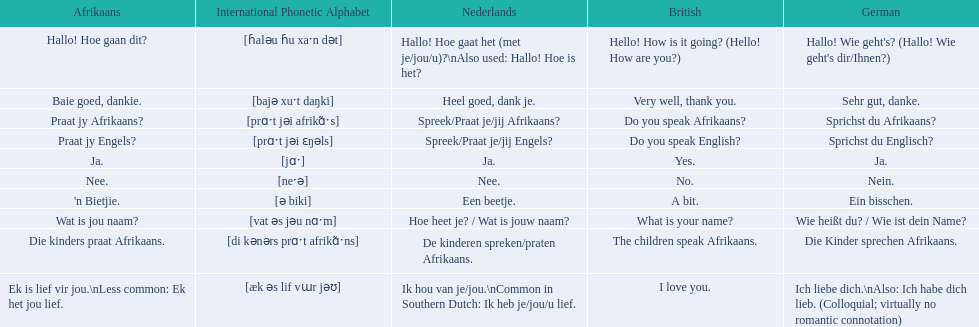In german how do you say do you speak afrikaans? Sprichst du Afrikaans?. Could you parse the entire table? {'header': ['Afrikaans', 'International Phonetic Alphabet', 'Nederlands', 'British', 'German'], 'rows': [['Hallo! Hoe gaan dit?', '[ɦaləu ɦu xaˑn dət]', 'Hallo! Hoe gaat het (met je/jou/u)?\\nAlso used: Hallo! Hoe is het?', 'Hello! How is it going? (Hello! How are you?)', "Hallo! Wie geht's? (Hallo! Wie geht's dir/Ihnen?)"], ['Baie goed, dankie.', '[bajə xuˑt daŋki]', 'Heel goed, dank je.', 'Very well, thank you.', 'Sehr gut, danke.'], ['Praat jy Afrikaans?', '[prɑˑt jəi afrikɑ̃ˑs]', 'Spreek/Praat je/jij Afrikaans?', 'Do you speak Afrikaans?', 'Sprichst du Afrikaans?'], ['Praat jy Engels?', '[prɑˑt jəi ɛŋəls]', 'Spreek/Praat je/jij Engels?', 'Do you speak English?', 'Sprichst du Englisch?'], ['Ja.', '[jɑˑ]', 'Ja.', 'Yes.', 'Ja.'], ['Nee.', '[neˑə]', 'Nee.', 'No.', 'Nein.'], ["'n Bietjie.", '[ə biki]', 'Een beetje.', 'A bit.', 'Ein bisschen.'], ['Wat is jou naam?', '[vat əs jəu nɑˑm]', 'Hoe heet je? / Wat is jouw naam?', 'What is your name?', 'Wie heißt du? / Wie ist dein Name?'], ['Die kinders praat Afrikaans.', '[di kənərs prɑˑt afrikɑ̃ˑns]', 'De kinderen spreken/praten Afrikaans.', 'The children speak Afrikaans.', 'Die Kinder sprechen Afrikaans.'], ['Ek is lief vir jou.\\nLess common: Ek het jou lief.', '[æk əs lif vɯr jəʊ]', 'Ik hou van je/jou.\\nCommon in Southern Dutch: Ik heb je/jou/u lief.', 'I love you.', 'Ich liebe dich.\\nAlso: Ich habe dich lieb. (Colloquial; virtually no romantic connotation)']]} How do you say it in afrikaans? Praat jy Afrikaans?. 